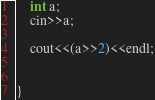Convert code to text. <code><loc_0><loc_0><loc_500><loc_500><_C++_>    int a;
    cin>>a;

    cout<<(a>>2)<<endl;


}</code> 